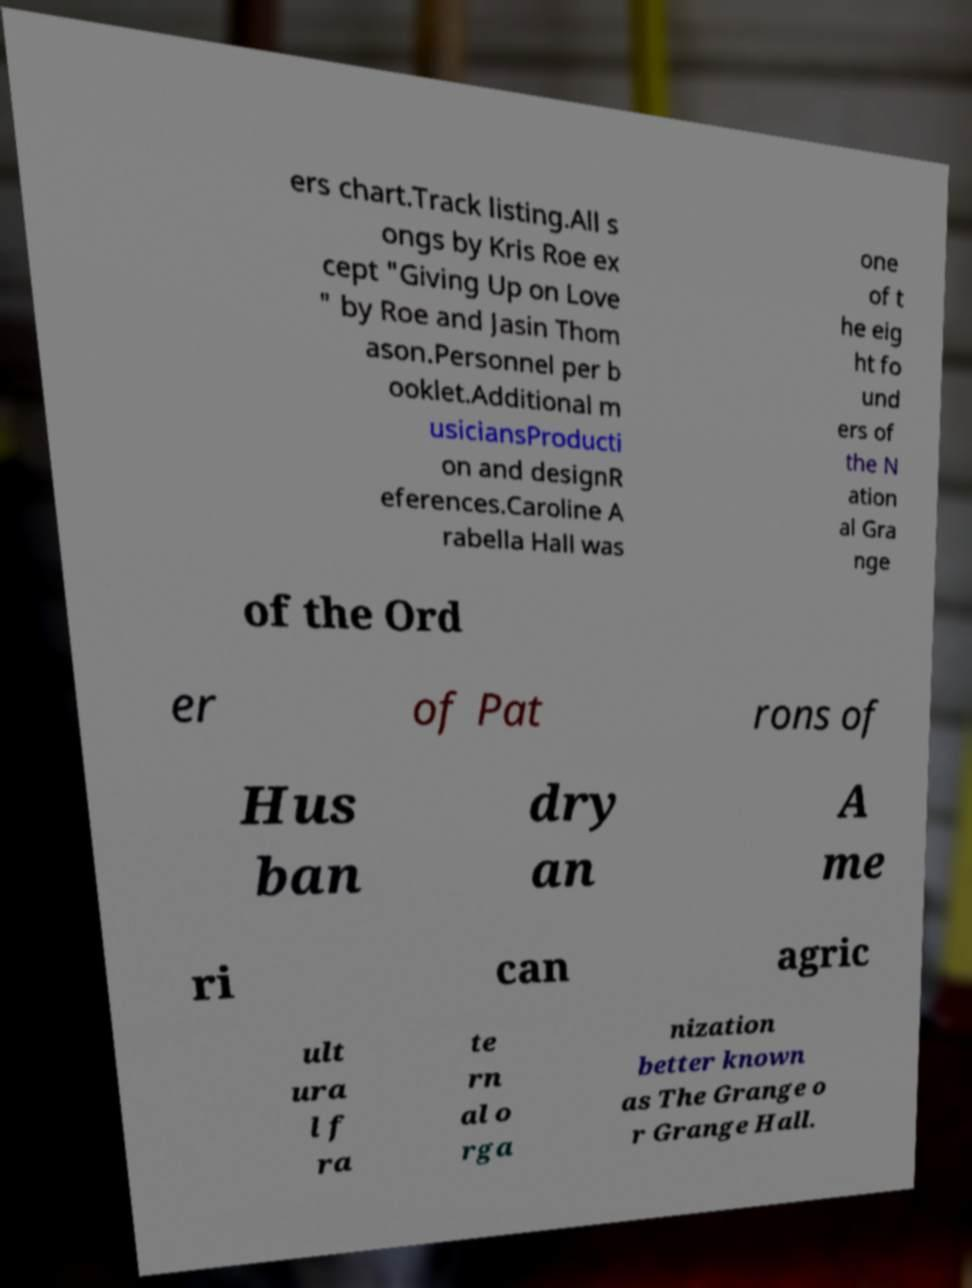Can you accurately transcribe the text from the provided image for me? ers chart.Track listing.All s ongs by Kris Roe ex cept "Giving Up on Love " by Roe and Jasin Thom ason.Personnel per b ooklet.Additional m usiciansProducti on and designR eferences.Caroline A rabella Hall was one of t he eig ht fo und ers of the N ation al Gra nge of the Ord er of Pat rons of Hus ban dry an A me ri can agric ult ura l f ra te rn al o rga nization better known as The Grange o r Grange Hall. 